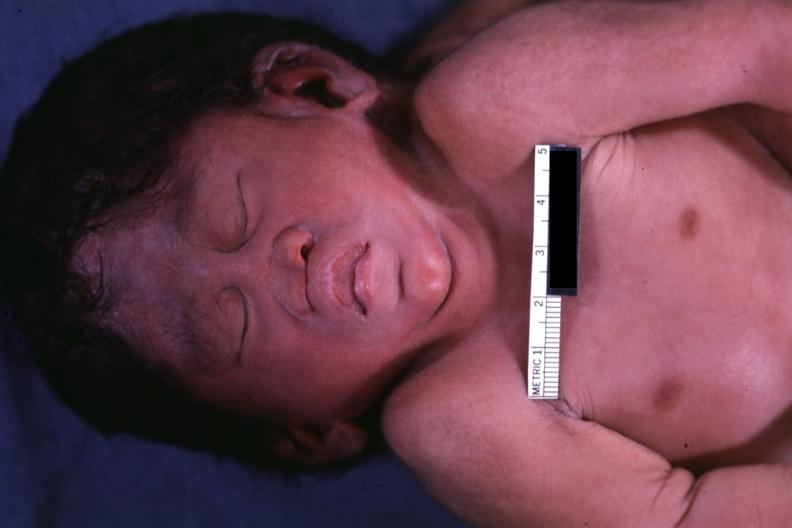does this image show close-up view of head anterior view?
Answer the question using a single word or phrase. Yes 